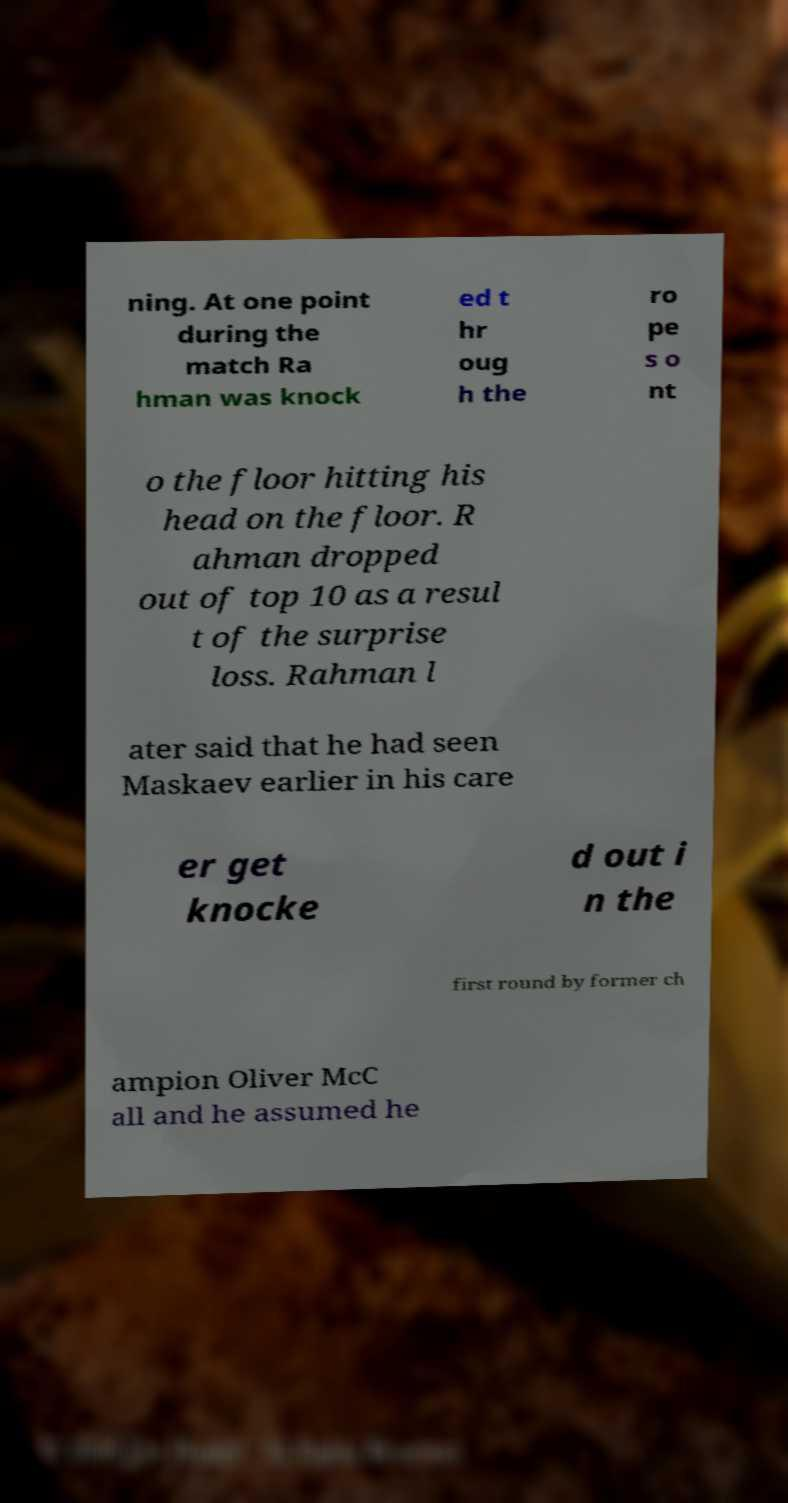Can you accurately transcribe the text from the provided image for me? ning. At one point during the match Ra hman was knock ed t hr oug h the ro pe s o nt o the floor hitting his head on the floor. R ahman dropped out of top 10 as a resul t of the surprise loss. Rahman l ater said that he had seen Maskaev earlier in his care er get knocke d out i n the first round by former ch ampion Oliver McC all and he assumed he 